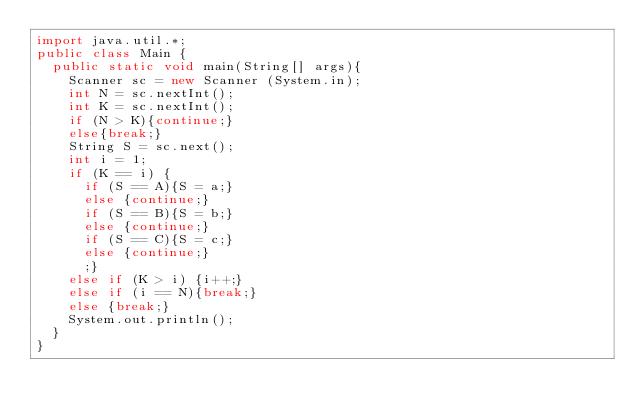Convert code to text. <code><loc_0><loc_0><loc_500><loc_500><_Java_>import java.util.*;
public class Main {
  public static void main(String[] args){
    Scanner sc = new Scanner (System.in);
    int N = sc.nextInt();
    int K = sc.nextInt();
    if (N > K){continue;}
    else{break;}
    String S = sc.next();
    int i = 1;
    if (K == i) {
    	if (S == A){S = a;}
    	else {continue;}
    	if (S == B){S = b;}
    	else {continue;}
    	if (S == C){S = c;}
    	else {continue;}
    	;}
    else if (K > i) {i++;}
    else if (i == N){break;}
    else {break;}
    System.out.println();
  }
}</code> 